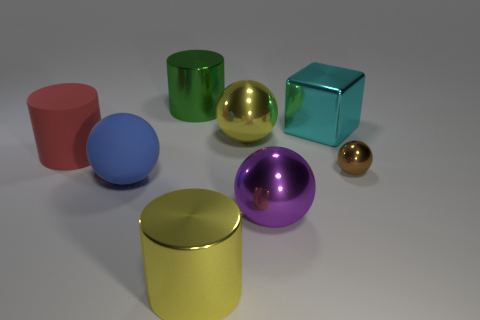There is a purple ball that is the same material as the big block; what size is it?
Provide a short and direct response. Large. Are there more purple spheres that are behind the blue sphere than tiny shiny spheres?
Your response must be concise. No. How big is the cylinder that is both right of the blue rubber thing and behind the small sphere?
Your answer should be very brief. Large. There is a big yellow thing that is the same shape as the green shiny thing; what material is it?
Your response must be concise. Metal. There is a metal cylinder that is in front of the rubber sphere; does it have the same size as the brown metallic thing?
Your answer should be very brief. No. There is a sphere that is both to the left of the purple thing and on the right side of the big blue sphere; what color is it?
Offer a terse response. Yellow. There is a cylinder to the left of the large green metal object; what number of red rubber objects are behind it?
Offer a terse response. 0. Does the red thing have the same shape as the brown thing?
Your response must be concise. No. Is there any other thing that has the same color as the shiny block?
Offer a very short reply. No. Do the large cyan shiny object and the yellow object that is in front of the brown metallic object have the same shape?
Your answer should be compact. No. 